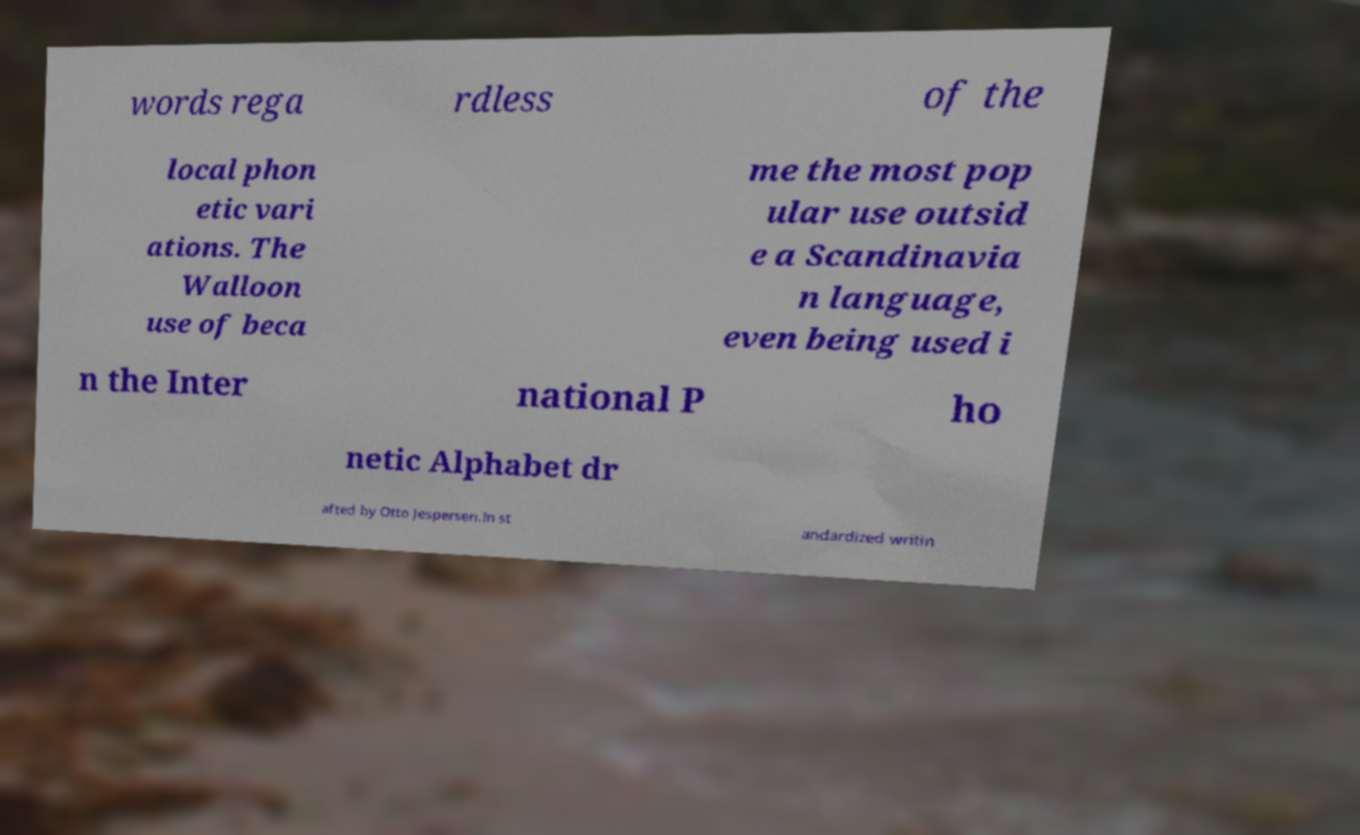Could you assist in decoding the text presented in this image and type it out clearly? words rega rdless of the local phon etic vari ations. The Walloon use of beca me the most pop ular use outsid e a Scandinavia n language, even being used i n the Inter national P ho netic Alphabet dr afted by Otto Jespersen.In st andardized writin 